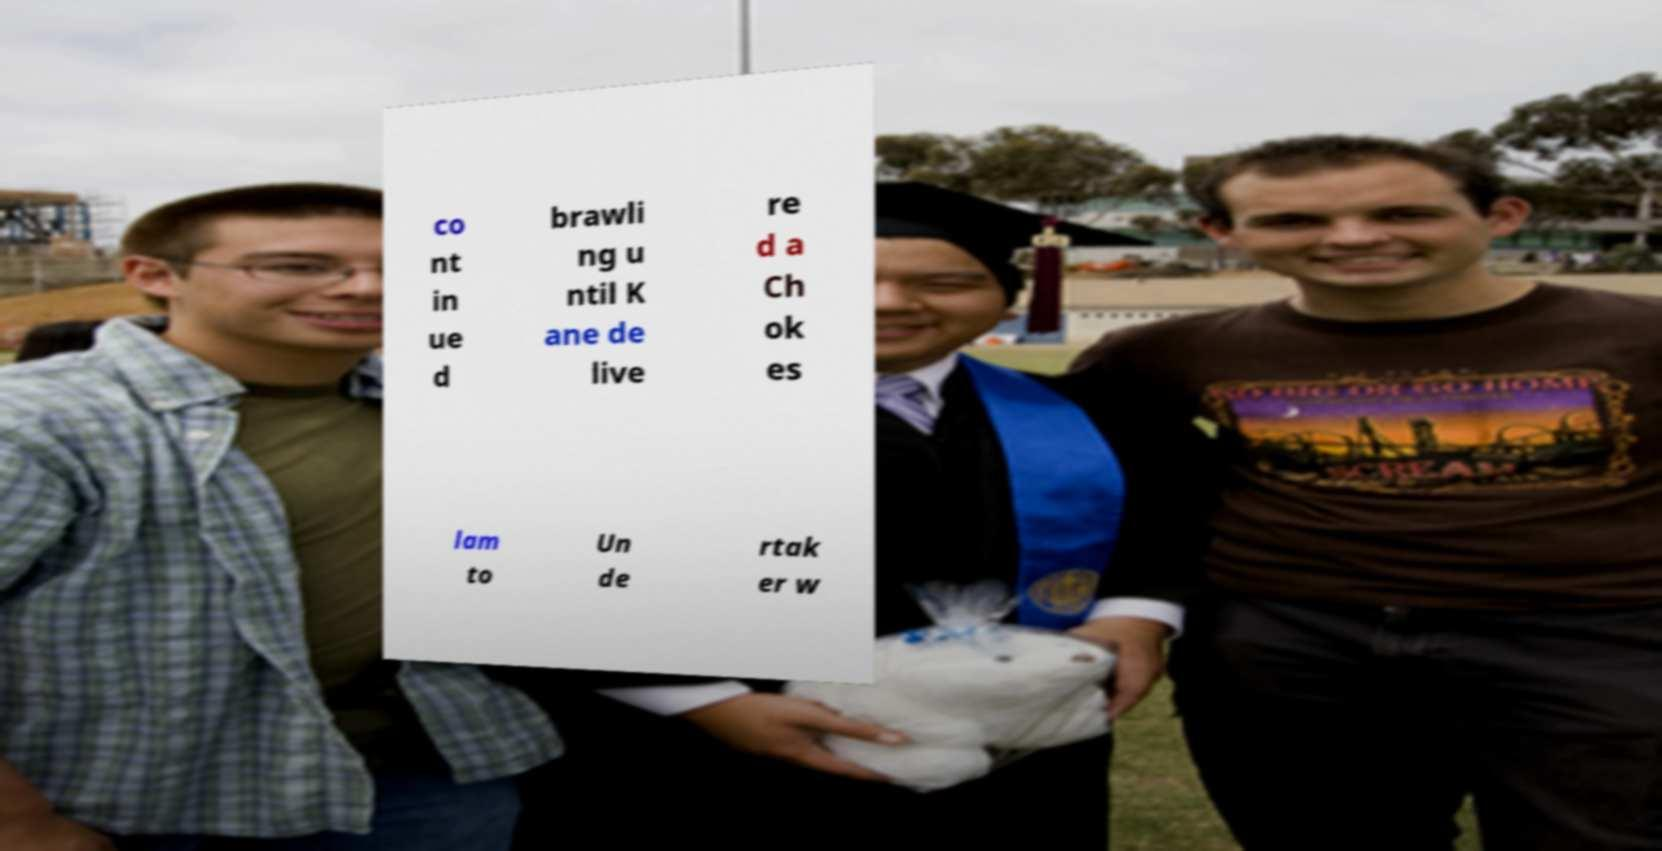Could you assist in decoding the text presented in this image and type it out clearly? co nt in ue d brawli ng u ntil K ane de live re d a Ch ok es lam to Un de rtak er w 